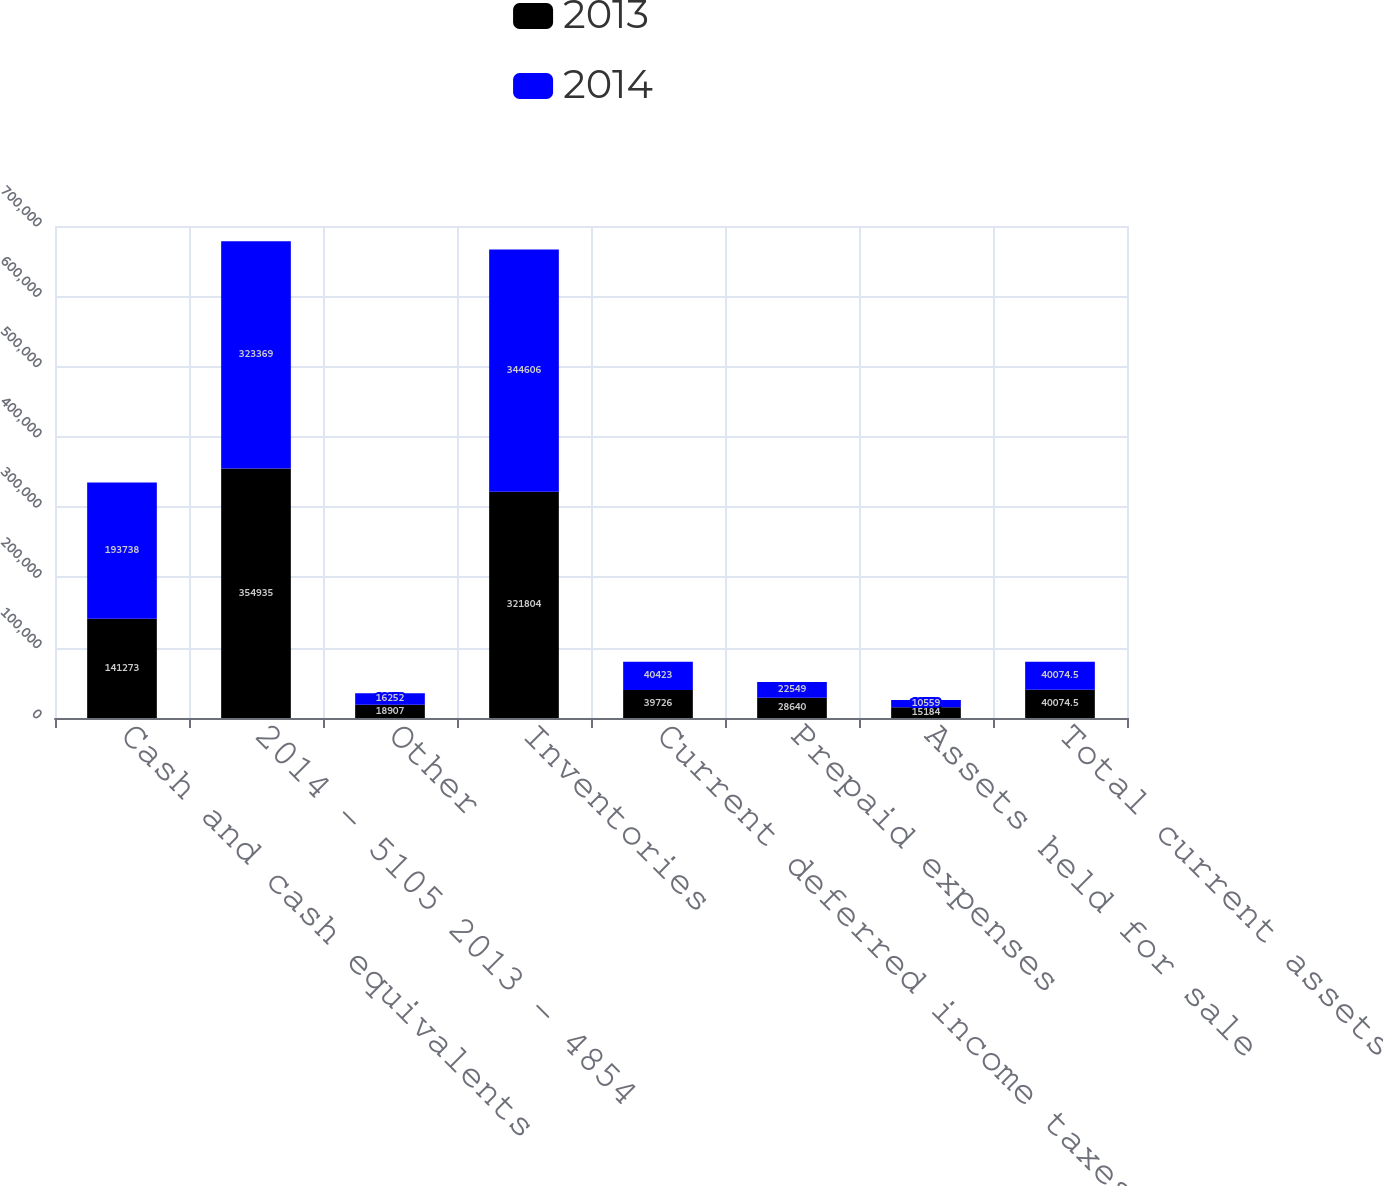Convert chart to OTSL. <chart><loc_0><loc_0><loc_500><loc_500><stacked_bar_chart><ecel><fcel>Cash and cash equivalents<fcel>2014 - 5105 2013 - 4854<fcel>Other<fcel>Inventories<fcel>Current deferred income taxes<fcel>Prepaid expenses<fcel>Assets held for sale<fcel>Total current assets<nl><fcel>2013<fcel>141273<fcel>354935<fcel>18907<fcel>321804<fcel>39726<fcel>28640<fcel>15184<fcel>40074.5<nl><fcel>2014<fcel>193738<fcel>323369<fcel>16252<fcel>344606<fcel>40423<fcel>22549<fcel>10559<fcel>40074.5<nl></chart> 